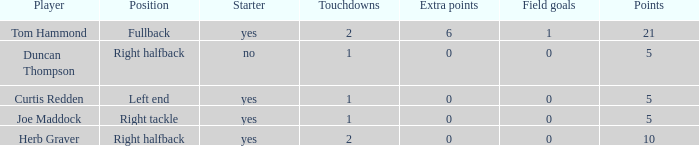Name the number of points for field goals being 1 1.0. Would you mind parsing the complete table? {'header': ['Player', 'Position', 'Starter', 'Touchdowns', 'Extra points', 'Field goals', 'Points'], 'rows': [['Tom Hammond', 'Fullback', 'yes', '2', '6', '1', '21'], ['Duncan Thompson', 'Right halfback', 'no', '1', '0', '0', '5'], ['Curtis Redden', 'Left end', 'yes', '1', '0', '0', '5'], ['Joe Maddock', 'Right tackle', 'yes', '1', '0', '0', '5'], ['Herb Graver', 'Right halfback', 'yes', '2', '0', '0', '10']]} 